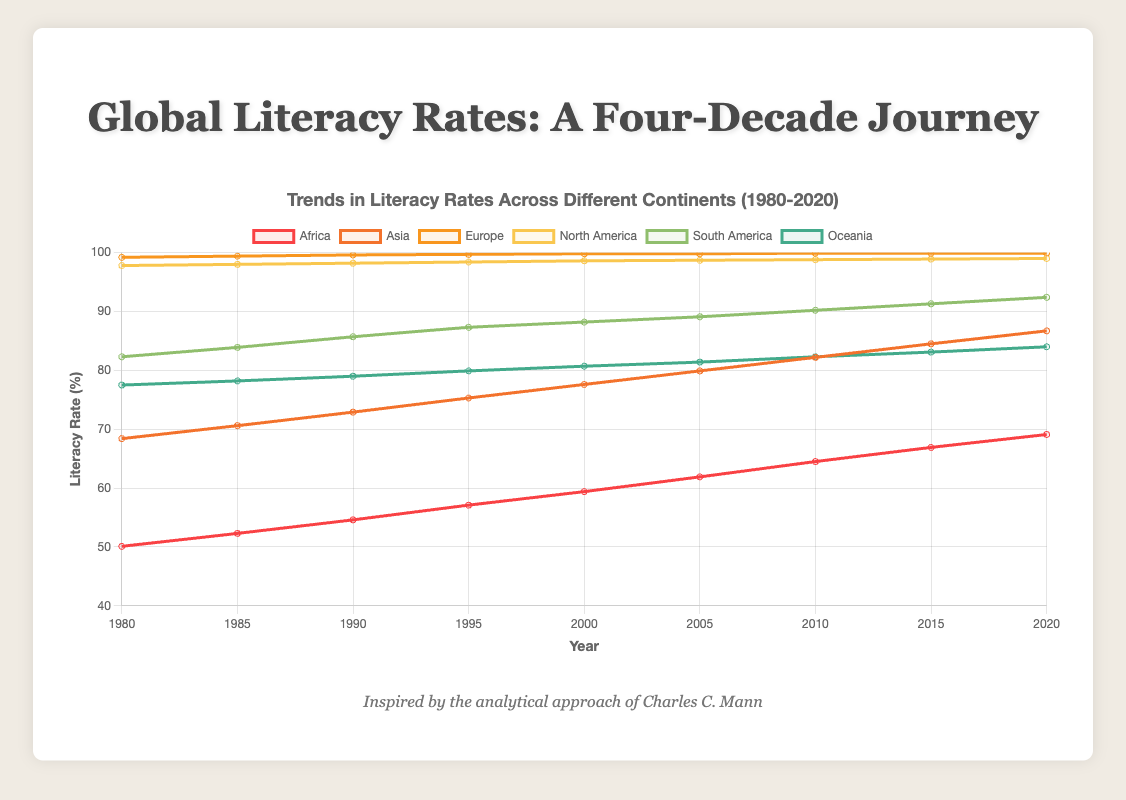How has Africa's literacy rate changed from 1980 to 2020? The literacy rate in Africa in 1980 was 50.1%. By 2020, it increased to 69.1%.
Answer: It increased by 19% Which continent had the highest literacy rate in 2020, and what was it? In 2020, Europe had the highest literacy rate, which was 99.9%.
Answer: Europe, 99.9% Between Asia and South America, which continent showed a greater increase in literacy rate from 1980 to 2020? Asia's literacy rate increased from 68.4% in 1980 to 86.7% in 2020, a change of 18.3 percentage points. South America's literacy rate increased from 82.3% in 1980 to 92.4% in 2020, a change of 10.1 percentage points. Therefore, Asia showed a greater increase.
Answer: Asia What is the average literacy rate of Oceania from 1980 to 2020? The literacy rates for Oceania for each year given are: 77.5, 78.2, 79.0, 79.9, 80.7, 81.4, 82.3, 83.1, 84.0. Sum these values and divide by the number of years (9): (77.5 + 78.2 + 79.0 + 79.9 + 80.7 + 81.4 + 82.3 + 83.1 + 84.0) / 9 = 80.7.
Answer: 80.7% Compare the literacy trends of Europe and North America from 1980 to 2020. Europe’s literacy rate increased slightly from 99.2% to 99.9%. North America's literacy rate increased from 97.8% to 99.0%. Both continents had high literacy rates from the start, with Europe maintaining near-perfect literacy throughout.
Answer: Europe had a stable high rate; North America had a slight increase In the latest year available, which continent saw the smallest improvement in literacy rate compared to 1980? The improvements in literacy rates from 1980 to 2020 are: Africa (19%), Asia (18.3%), Europe (0.7%), North America (1.2%), South America (10.1%), and Oceania (6.5%). Europe saw the smallest improvement, with an increase of only 0.7%.
Answer: Europe What is the difference in literacy rates between the highest and lowest continents in 1990? In 1990, the highest literacy rate was in Europe (99.6%), and the lowest was in Africa (54.6%). The difference is 99.6% - 54.6% = 45%.
Answer: 45% What trend can be observed in the literacy rate of South America from 1980 to 2020? The literacy rate in South America increased steadily from 82.3% in 1980 to 92.4% in 2020, indicating a consistent improvement over the 40 years.
Answer: Steady increase Identify and explain one notable insight from the trends in Asia’s literacy rate between 1980 and 2020. Asia’s literacy rate increased from 68.4% to 86.7%, showing significant improvement. The rate of increase was relatively steady, highlighting continuous efforts in educational initiatives across the continent.
Answer: Significant and steady improvement 